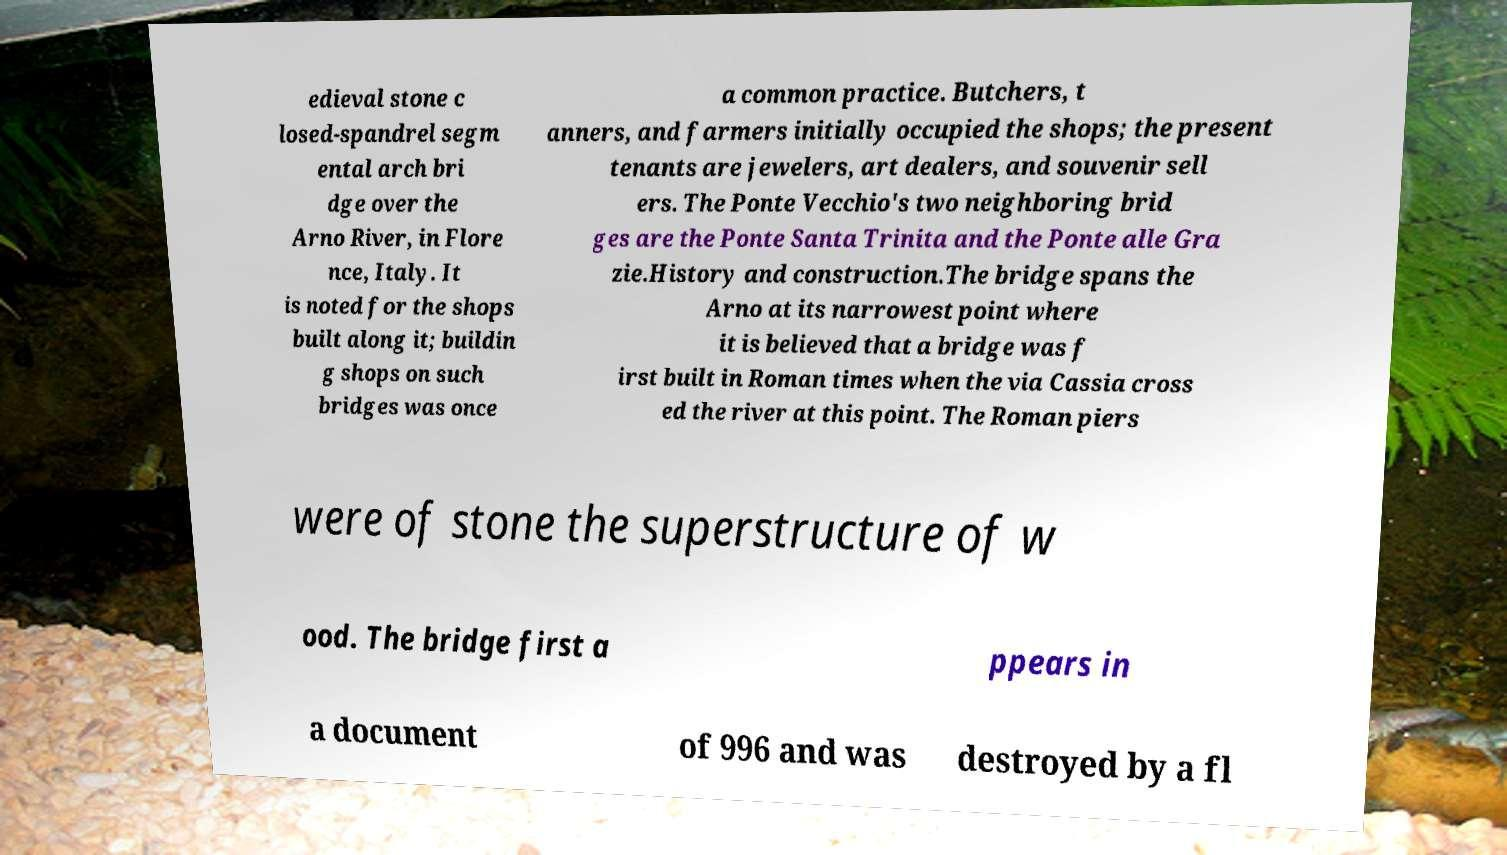For documentation purposes, I need the text within this image transcribed. Could you provide that? edieval stone c losed-spandrel segm ental arch bri dge over the Arno River, in Flore nce, Italy. It is noted for the shops built along it; buildin g shops on such bridges was once a common practice. Butchers, t anners, and farmers initially occupied the shops; the present tenants are jewelers, art dealers, and souvenir sell ers. The Ponte Vecchio's two neighboring brid ges are the Ponte Santa Trinita and the Ponte alle Gra zie.History and construction.The bridge spans the Arno at its narrowest point where it is believed that a bridge was f irst built in Roman times when the via Cassia cross ed the river at this point. The Roman piers were of stone the superstructure of w ood. The bridge first a ppears in a document of 996 and was destroyed by a fl 